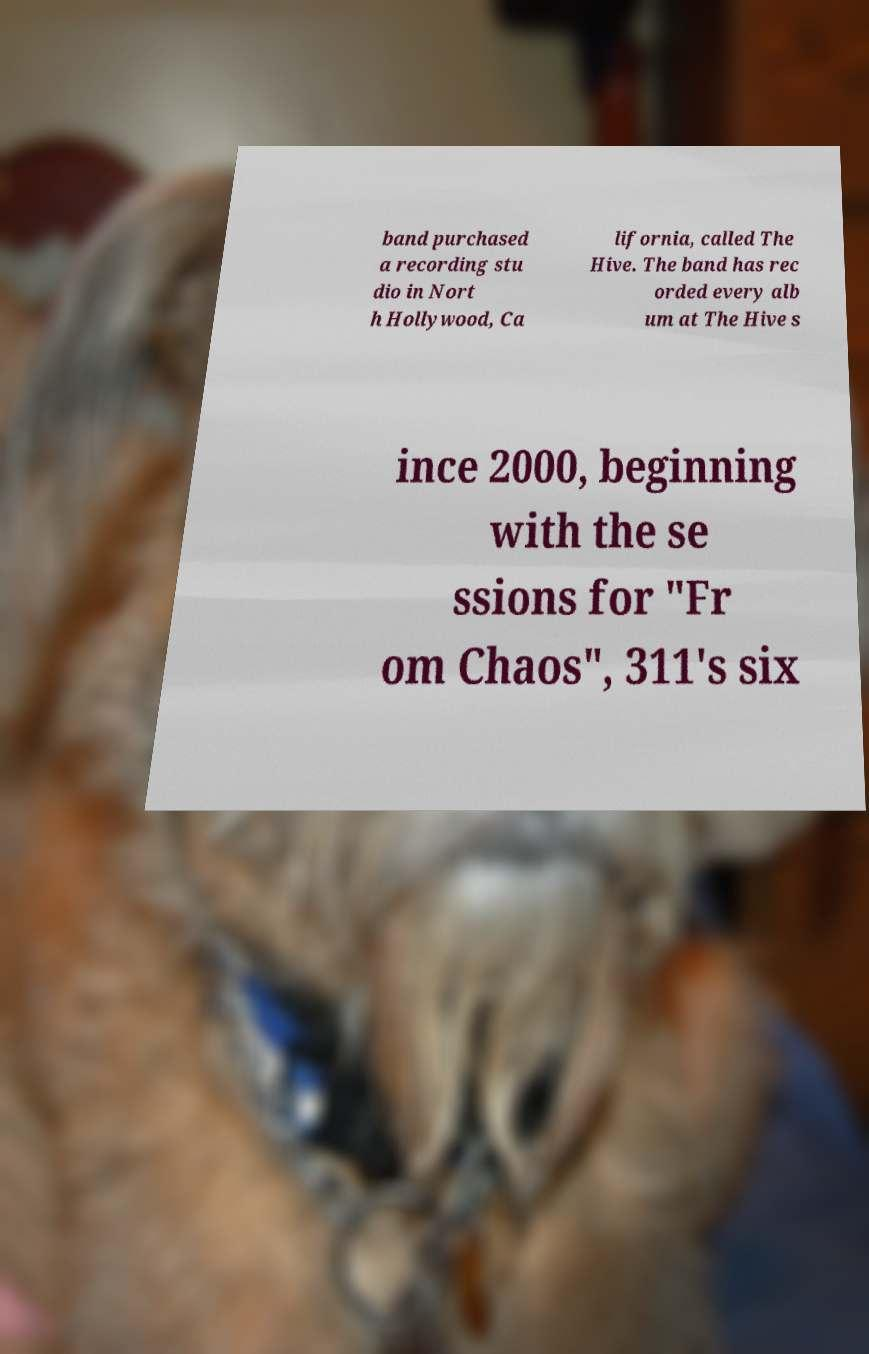For documentation purposes, I need the text within this image transcribed. Could you provide that? band purchased a recording stu dio in Nort h Hollywood, Ca lifornia, called The Hive. The band has rec orded every alb um at The Hive s ince 2000, beginning with the se ssions for "Fr om Chaos", 311's six 